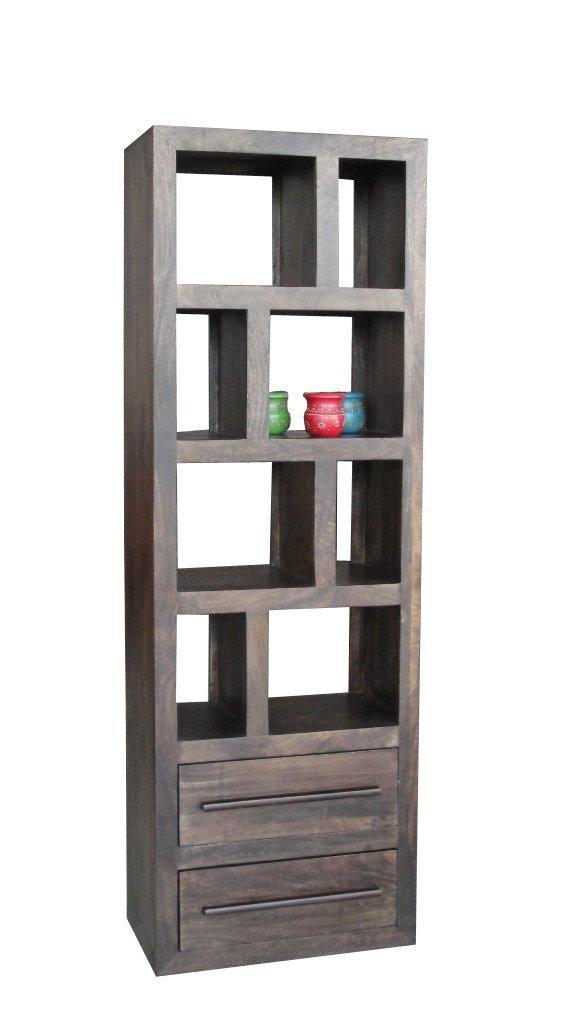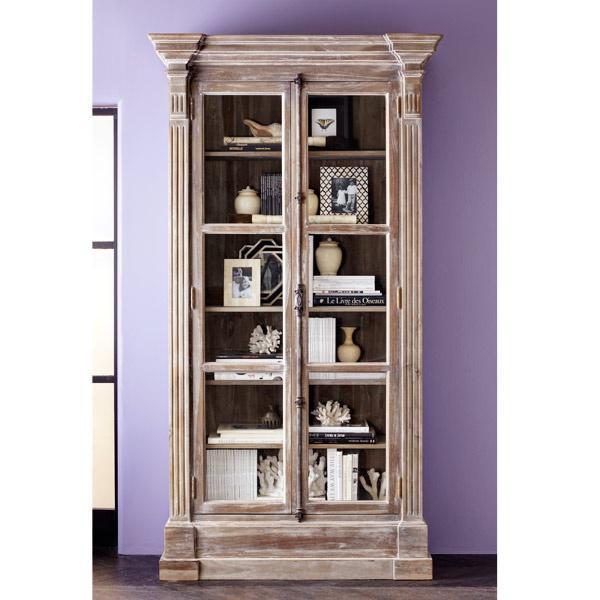The first image is the image on the left, the second image is the image on the right. For the images shown, is this caption "The left image shows a dark bookcase with short legs, a top part that is open, and a bottom part at least partly closed." true? Answer yes or no. No. The first image is the image on the left, the second image is the image on the right. For the images shown, is this caption "Both shelf units can stand on their own." true? Answer yes or no. Yes. 